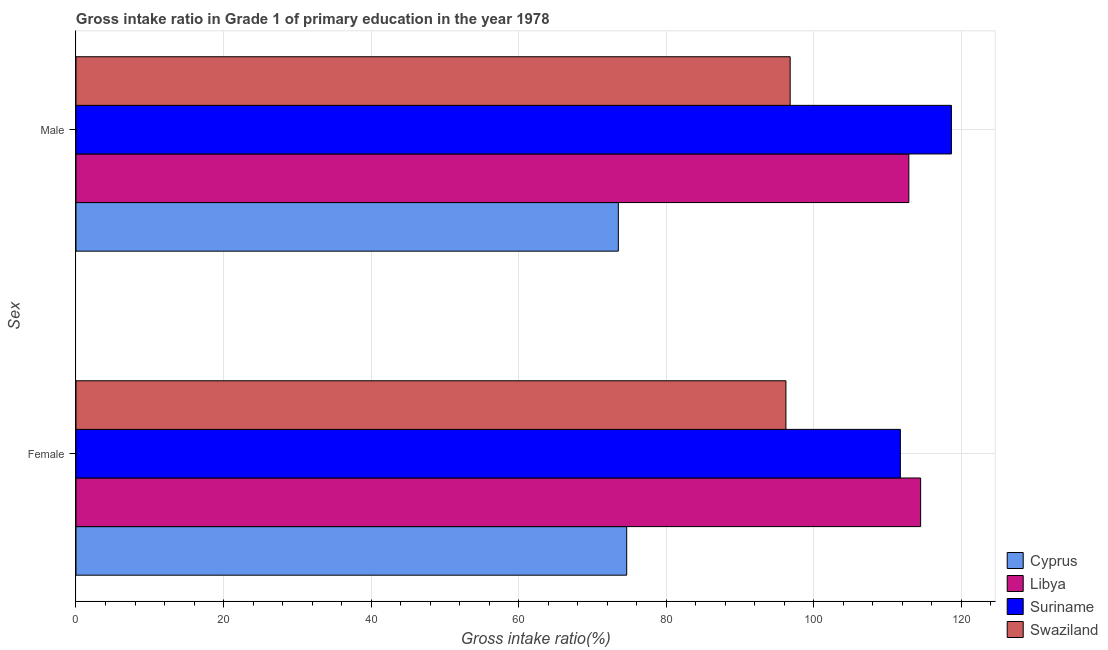How many bars are there on the 1st tick from the top?
Your response must be concise. 4. What is the label of the 1st group of bars from the top?
Offer a very short reply. Male. What is the gross intake ratio(female) in Swaziland?
Your response must be concise. 96.23. Across all countries, what is the maximum gross intake ratio(female)?
Keep it short and to the point. 114.49. Across all countries, what is the minimum gross intake ratio(female)?
Your answer should be compact. 74.64. In which country was the gross intake ratio(female) maximum?
Give a very brief answer. Libya. In which country was the gross intake ratio(male) minimum?
Offer a terse response. Cyprus. What is the total gross intake ratio(female) in the graph?
Provide a short and direct response. 397.1. What is the difference between the gross intake ratio(male) in Cyprus and that in Suriname?
Provide a short and direct response. -45.15. What is the difference between the gross intake ratio(female) in Suriname and the gross intake ratio(male) in Cyprus?
Make the answer very short. 38.23. What is the average gross intake ratio(female) per country?
Offer a very short reply. 99.27. What is the difference between the gross intake ratio(female) and gross intake ratio(male) in Suriname?
Your response must be concise. -6.92. In how many countries, is the gross intake ratio(male) greater than 72 %?
Your answer should be compact. 4. What is the ratio of the gross intake ratio(male) in Swaziland to that in Suriname?
Provide a succinct answer. 0.82. What does the 2nd bar from the top in Male represents?
Provide a succinct answer. Suriname. What does the 3rd bar from the bottom in Male represents?
Keep it short and to the point. Suriname. Are all the bars in the graph horizontal?
Make the answer very short. Yes. Are the values on the major ticks of X-axis written in scientific E-notation?
Offer a very short reply. No. Does the graph contain any zero values?
Give a very brief answer. No. How many legend labels are there?
Provide a succinct answer. 4. How are the legend labels stacked?
Your answer should be compact. Vertical. What is the title of the graph?
Make the answer very short. Gross intake ratio in Grade 1 of primary education in the year 1978. Does "Madagascar" appear as one of the legend labels in the graph?
Give a very brief answer. No. What is the label or title of the X-axis?
Your response must be concise. Gross intake ratio(%). What is the label or title of the Y-axis?
Give a very brief answer. Sex. What is the Gross intake ratio(%) in Cyprus in Female?
Make the answer very short. 74.64. What is the Gross intake ratio(%) of Libya in Female?
Your response must be concise. 114.49. What is the Gross intake ratio(%) of Suriname in Female?
Your response must be concise. 111.74. What is the Gross intake ratio(%) in Swaziland in Female?
Your answer should be compact. 96.23. What is the Gross intake ratio(%) of Cyprus in Male?
Offer a terse response. 73.51. What is the Gross intake ratio(%) of Libya in Male?
Your answer should be compact. 112.89. What is the Gross intake ratio(%) of Suriname in Male?
Keep it short and to the point. 118.66. What is the Gross intake ratio(%) of Swaziland in Male?
Provide a short and direct response. 96.8. Across all Sex, what is the maximum Gross intake ratio(%) in Cyprus?
Your response must be concise. 74.64. Across all Sex, what is the maximum Gross intake ratio(%) in Libya?
Ensure brevity in your answer.  114.49. Across all Sex, what is the maximum Gross intake ratio(%) of Suriname?
Give a very brief answer. 118.66. Across all Sex, what is the maximum Gross intake ratio(%) of Swaziland?
Your answer should be very brief. 96.8. Across all Sex, what is the minimum Gross intake ratio(%) of Cyprus?
Provide a succinct answer. 73.51. Across all Sex, what is the minimum Gross intake ratio(%) in Libya?
Make the answer very short. 112.89. Across all Sex, what is the minimum Gross intake ratio(%) of Suriname?
Make the answer very short. 111.74. Across all Sex, what is the minimum Gross intake ratio(%) in Swaziland?
Your answer should be very brief. 96.23. What is the total Gross intake ratio(%) in Cyprus in the graph?
Keep it short and to the point. 148.15. What is the total Gross intake ratio(%) in Libya in the graph?
Offer a very short reply. 227.37. What is the total Gross intake ratio(%) in Suriname in the graph?
Offer a very short reply. 230.4. What is the total Gross intake ratio(%) in Swaziland in the graph?
Give a very brief answer. 193.03. What is the difference between the Gross intake ratio(%) of Cyprus in Female and that in Male?
Your answer should be very brief. 1.13. What is the difference between the Gross intake ratio(%) in Libya in Female and that in Male?
Provide a short and direct response. 1.6. What is the difference between the Gross intake ratio(%) in Suriname in Female and that in Male?
Offer a terse response. -6.92. What is the difference between the Gross intake ratio(%) in Swaziland in Female and that in Male?
Ensure brevity in your answer.  -0.58. What is the difference between the Gross intake ratio(%) of Cyprus in Female and the Gross intake ratio(%) of Libya in Male?
Your response must be concise. -38.24. What is the difference between the Gross intake ratio(%) in Cyprus in Female and the Gross intake ratio(%) in Suriname in Male?
Keep it short and to the point. -44.01. What is the difference between the Gross intake ratio(%) of Cyprus in Female and the Gross intake ratio(%) of Swaziland in Male?
Make the answer very short. -22.16. What is the difference between the Gross intake ratio(%) in Libya in Female and the Gross intake ratio(%) in Suriname in Male?
Give a very brief answer. -4.17. What is the difference between the Gross intake ratio(%) of Libya in Female and the Gross intake ratio(%) of Swaziland in Male?
Ensure brevity in your answer.  17.68. What is the difference between the Gross intake ratio(%) in Suriname in Female and the Gross intake ratio(%) in Swaziland in Male?
Your response must be concise. 14.94. What is the average Gross intake ratio(%) of Cyprus per Sex?
Give a very brief answer. 74.08. What is the average Gross intake ratio(%) in Libya per Sex?
Offer a terse response. 113.69. What is the average Gross intake ratio(%) of Suriname per Sex?
Offer a terse response. 115.2. What is the average Gross intake ratio(%) in Swaziland per Sex?
Ensure brevity in your answer.  96.51. What is the difference between the Gross intake ratio(%) in Cyprus and Gross intake ratio(%) in Libya in Female?
Offer a very short reply. -39.84. What is the difference between the Gross intake ratio(%) of Cyprus and Gross intake ratio(%) of Suriname in Female?
Give a very brief answer. -37.09. What is the difference between the Gross intake ratio(%) in Cyprus and Gross intake ratio(%) in Swaziland in Female?
Keep it short and to the point. -21.58. What is the difference between the Gross intake ratio(%) in Libya and Gross intake ratio(%) in Suriname in Female?
Your answer should be very brief. 2.75. What is the difference between the Gross intake ratio(%) of Libya and Gross intake ratio(%) of Swaziland in Female?
Ensure brevity in your answer.  18.26. What is the difference between the Gross intake ratio(%) of Suriname and Gross intake ratio(%) of Swaziland in Female?
Your answer should be compact. 15.51. What is the difference between the Gross intake ratio(%) of Cyprus and Gross intake ratio(%) of Libya in Male?
Keep it short and to the point. -39.38. What is the difference between the Gross intake ratio(%) of Cyprus and Gross intake ratio(%) of Suriname in Male?
Offer a terse response. -45.15. What is the difference between the Gross intake ratio(%) in Cyprus and Gross intake ratio(%) in Swaziland in Male?
Provide a succinct answer. -23.29. What is the difference between the Gross intake ratio(%) of Libya and Gross intake ratio(%) of Suriname in Male?
Make the answer very short. -5.77. What is the difference between the Gross intake ratio(%) of Libya and Gross intake ratio(%) of Swaziland in Male?
Offer a very short reply. 16.08. What is the difference between the Gross intake ratio(%) of Suriname and Gross intake ratio(%) of Swaziland in Male?
Give a very brief answer. 21.86. What is the ratio of the Gross intake ratio(%) of Cyprus in Female to that in Male?
Provide a short and direct response. 1.02. What is the ratio of the Gross intake ratio(%) in Libya in Female to that in Male?
Your answer should be very brief. 1.01. What is the ratio of the Gross intake ratio(%) in Suriname in Female to that in Male?
Provide a succinct answer. 0.94. What is the difference between the highest and the second highest Gross intake ratio(%) of Cyprus?
Your answer should be very brief. 1.13. What is the difference between the highest and the second highest Gross intake ratio(%) of Libya?
Your response must be concise. 1.6. What is the difference between the highest and the second highest Gross intake ratio(%) of Suriname?
Make the answer very short. 6.92. What is the difference between the highest and the second highest Gross intake ratio(%) in Swaziland?
Offer a terse response. 0.58. What is the difference between the highest and the lowest Gross intake ratio(%) of Cyprus?
Give a very brief answer. 1.13. What is the difference between the highest and the lowest Gross intake ratio(%) in Libya?
Ensure brevity in your answer.  1.6. What is the difference between the highest and the lowest Gross intake ratio(%) of Suriname?
Offer a terse response. 6.92. What is the difference between the highest and the lowest Gross intake ratio(%) of Swaziland?
Your answer should be compact. 0.58. 